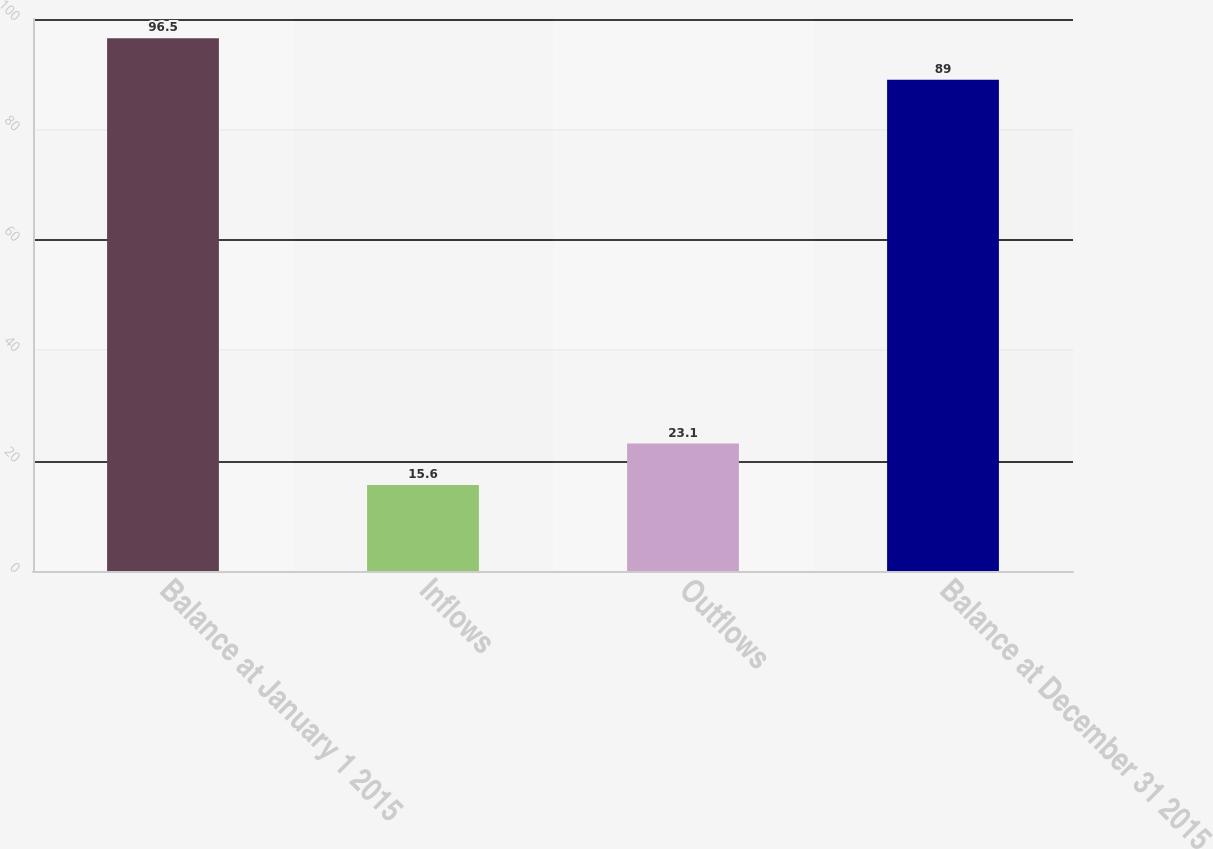<chart> <loc_0><loc_0><loc_500><loc_500><bar_chart><fcel>Balance at January 1 2015<fcel>Inflows<fcel>Outflows<fcel>Balance at December 31 2015<nl><fcel>96.5<fcel>15.6<fcel>23.1<fcel>89<nl></chart> 